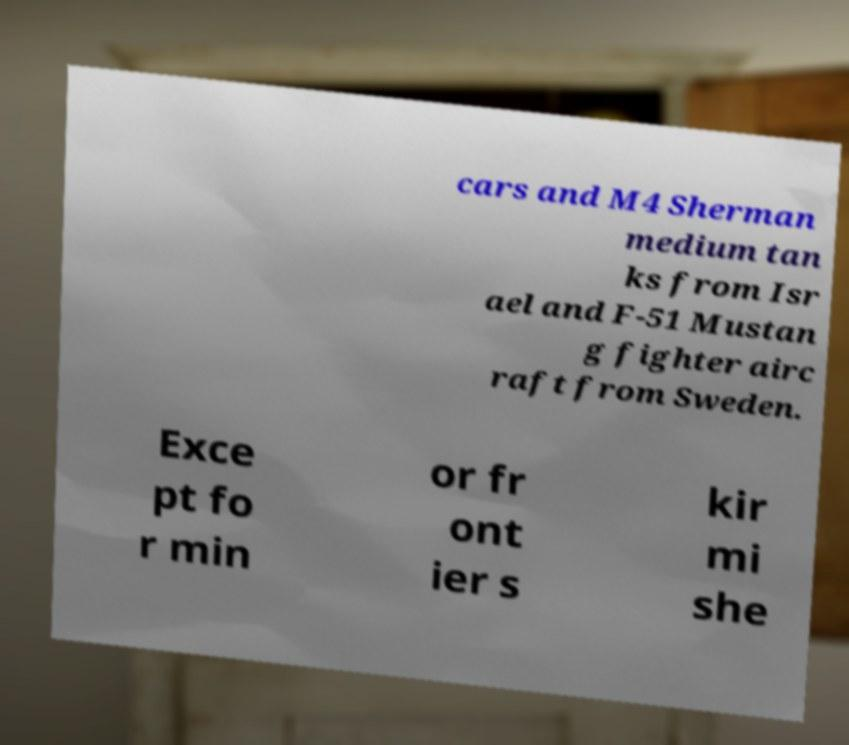I need the written content from this picture converted into text. Can you do that? cars and M4 Sherman medium tan ks from Isr ael and F-51 Mustan g fighter airc raft from Sweden. Exce pt fo r min or fr ont ier s kir mi she 